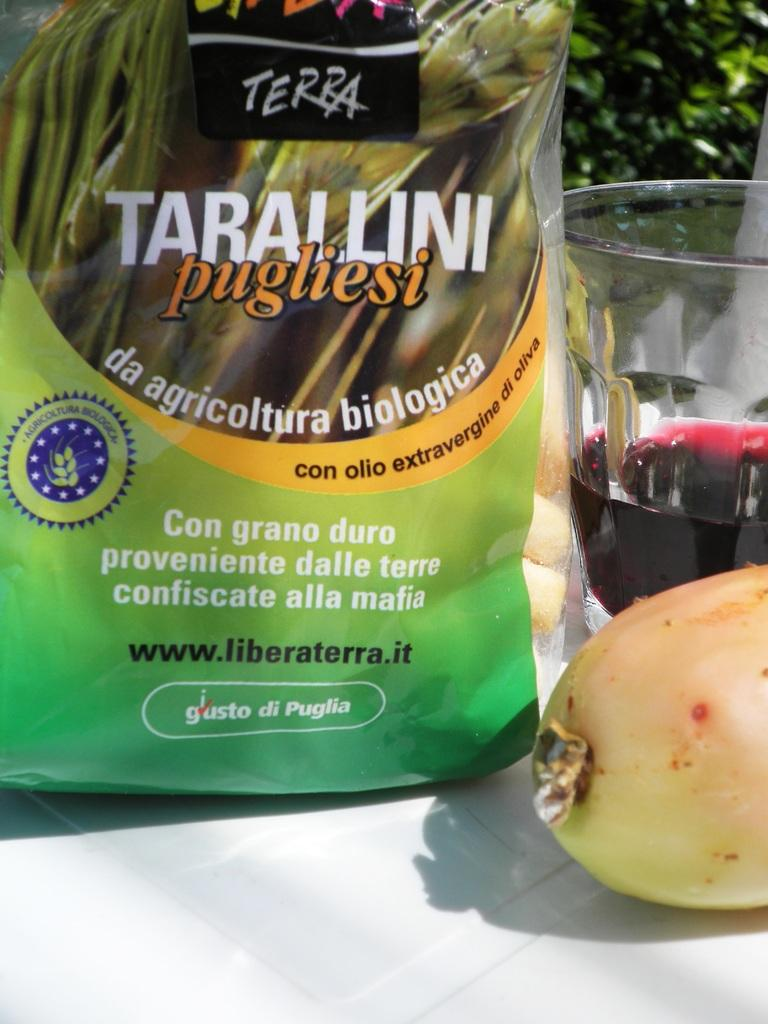<image>
Give a short and clear explanation of the subsequent image. A bag of Terra Tarallini sits next to a wine glass. 